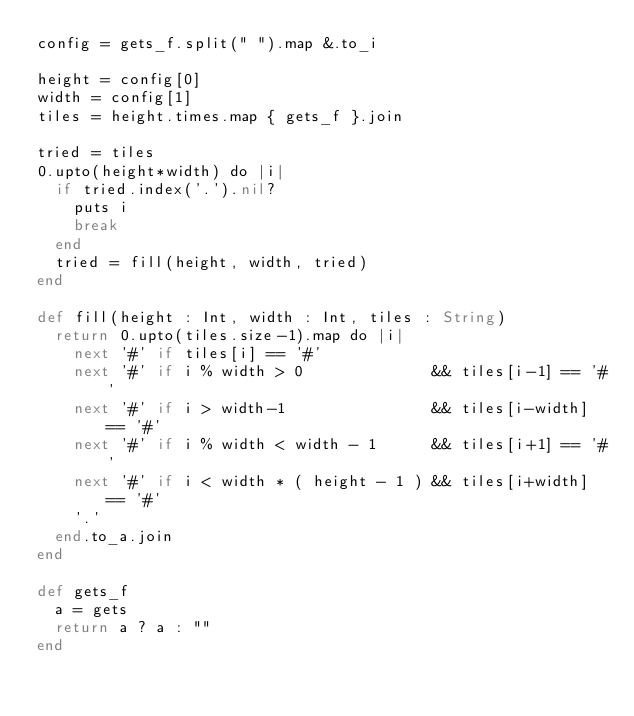Convert code to text. <code><loc_0><loc_0><loc_500><loc_500><_Crystal_>config = gets_f.split(" ").map &.to_i

height = config[0]
width = config[1]
tiles = height.times.map { gets_f }.join

tried = tiles
0.upto(height*width) do |i|
  if tried.index('.').nil?
    puts i
    break
  end
  tried = fill(height, width, tried)
end

def fill(height : Int, width : Int, tiles : String)
  return 0.upto(tiles.size-1).map do |i|
    next '#' if tiles[i] == '#'
    next '#' if i % width > 0              && tiles[i-1] == '#'
    next '#' if i > width-1                && tiles[i-width] == '#'
    next '#' if i % width < width - 1      && tiles[i+1] == '#' 
    next '#' if i < width * ( height - 1 ) && tiles[i+width] == '#'
    '.'
  end.to_a.join
end

def gets_f
  a = gets
  return a ? a : ""
end
</code> 